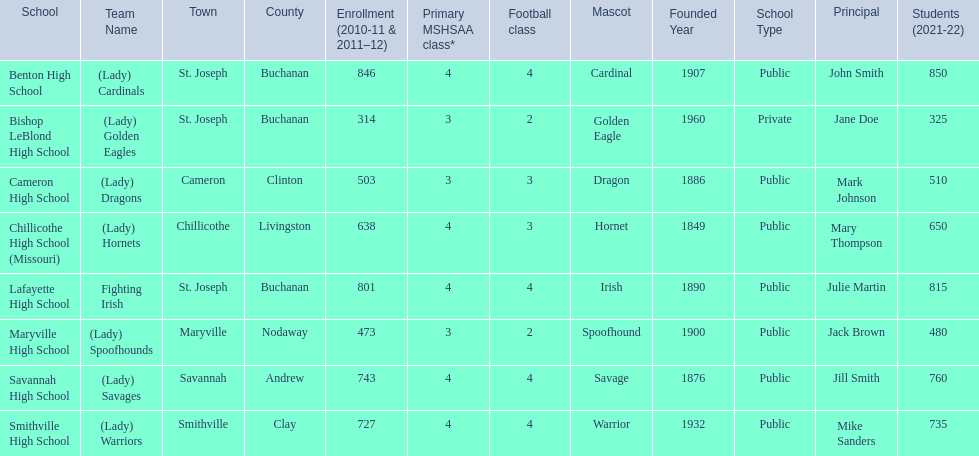What schools are located in st. joseph? Benton High School, Bishop LeBlond High School, Lafayette High School. Which st. joseph schools have more then 800 enrollment  for 2010-11 7 2011-12? Benton High School, Lafayette High School. What is the name of the st. joseph school with 800 or more enrollment's team names is a not a (lady)? Lafayette High School. 